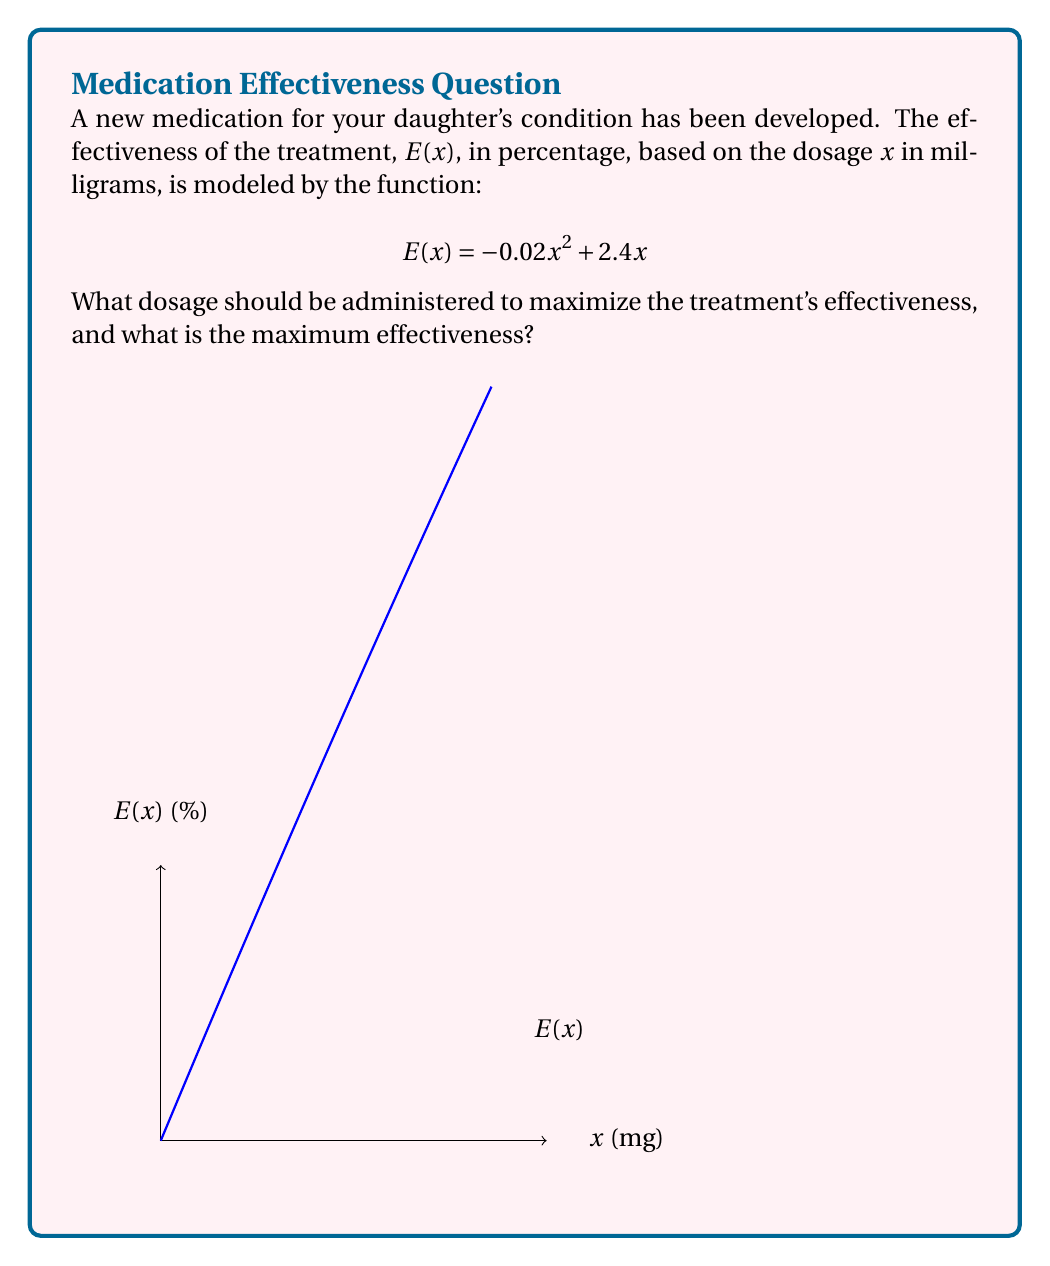Solve this math problem. To find the maximum effectiveness of the treatment, we need to optimize the function $E(x)$.

1) First, we find the derivative of $E(x)$:
   $$E'(x) = -0.04x + 2.4$$

2) To find the critical point, we set $E'(x) = 0$:
   $$-0.04x + 2.4 = 0$$
   $$-0.04x = -2.4$$
   $$x = 60$$

3) The second derivative is:
   $$E''(x) = -0.04$$
   Since $E''(x)$ is negative, the critical point is a maximum.

4) The optimal dosage is 60 mg.

5) To find the maximum effectiveness, we substitute $x = 60$ into the original function:
   $$E(60) = -0.02(60)^2 + 2.4(60)$$
   $$= -0.02(3600) + 144$$
   $$= -72 + 144 = 72$$

Therefore, the maximum effectiveness is 72%.
Answer: Optimal dosage: 60 mg; Maximum effectiveness: 72% 